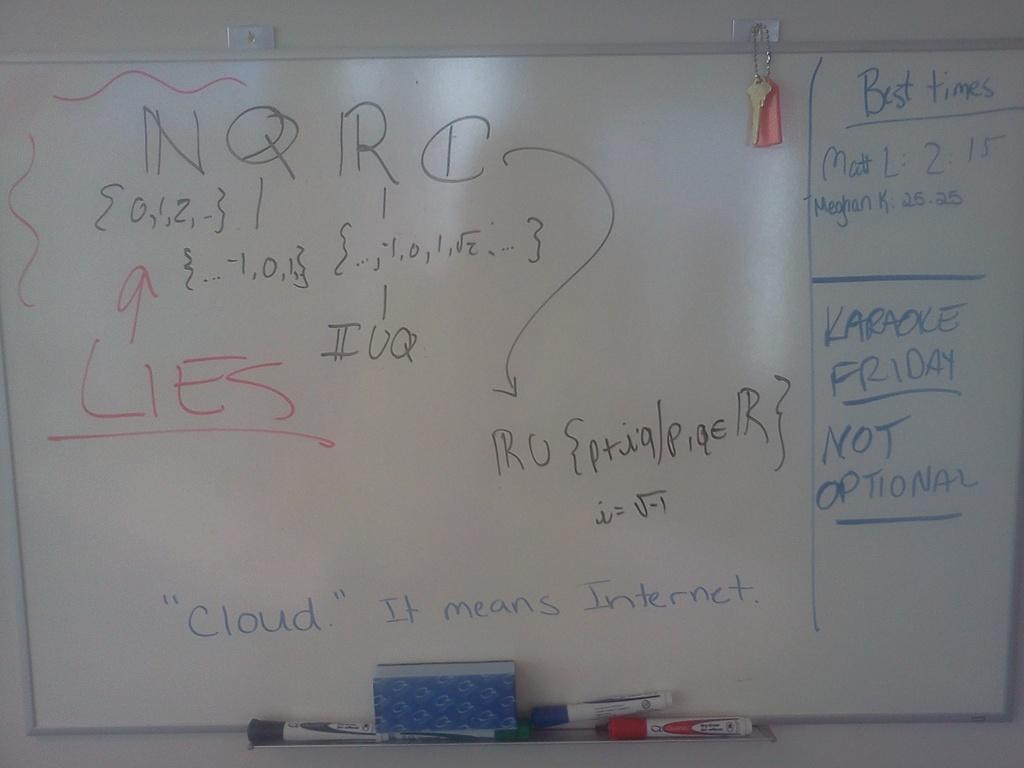<image>
Provide a brief description of the given image. whiteboard with with equation and  "cloud" it means internet at the bottom 